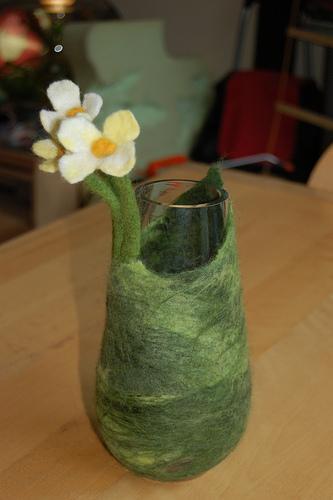How many flowers are pictured?
Give a very brief answer. 3. 